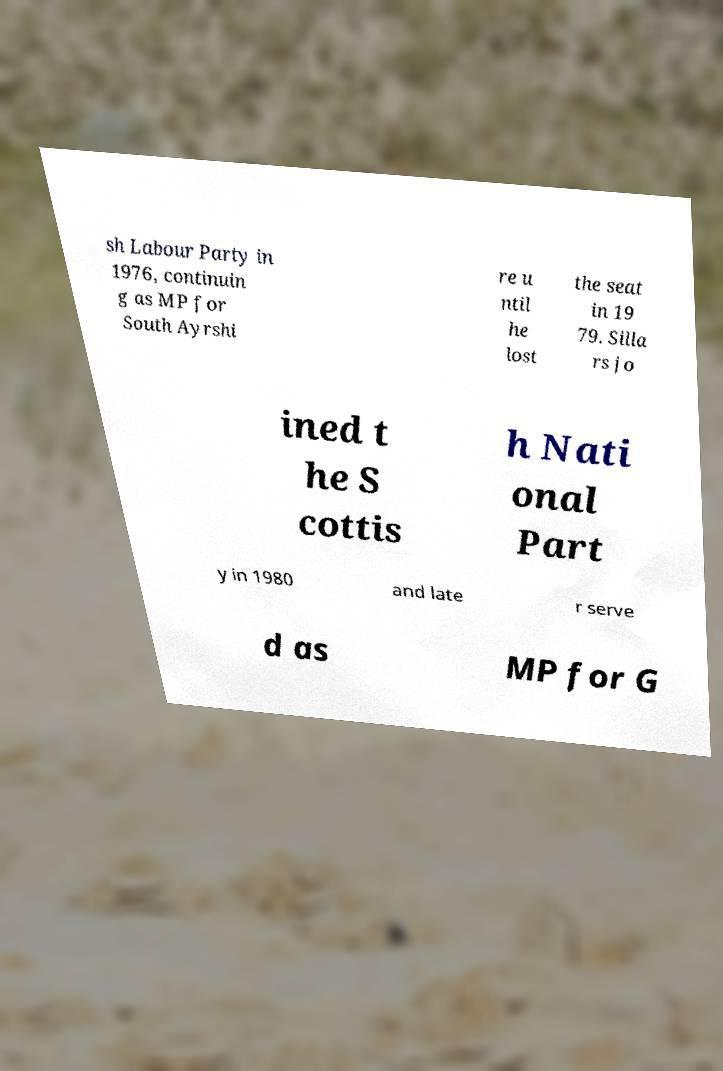Can you accurately transcribe the text from the provided image for me? sh Labour Party in 1976, continuin g as MP for South Ayrshi re u ntil he lost the seat in 19 79. Silla rs jo ined t he S cottis h Nati onal Part y in 1980 and late r serve d as MP for G 